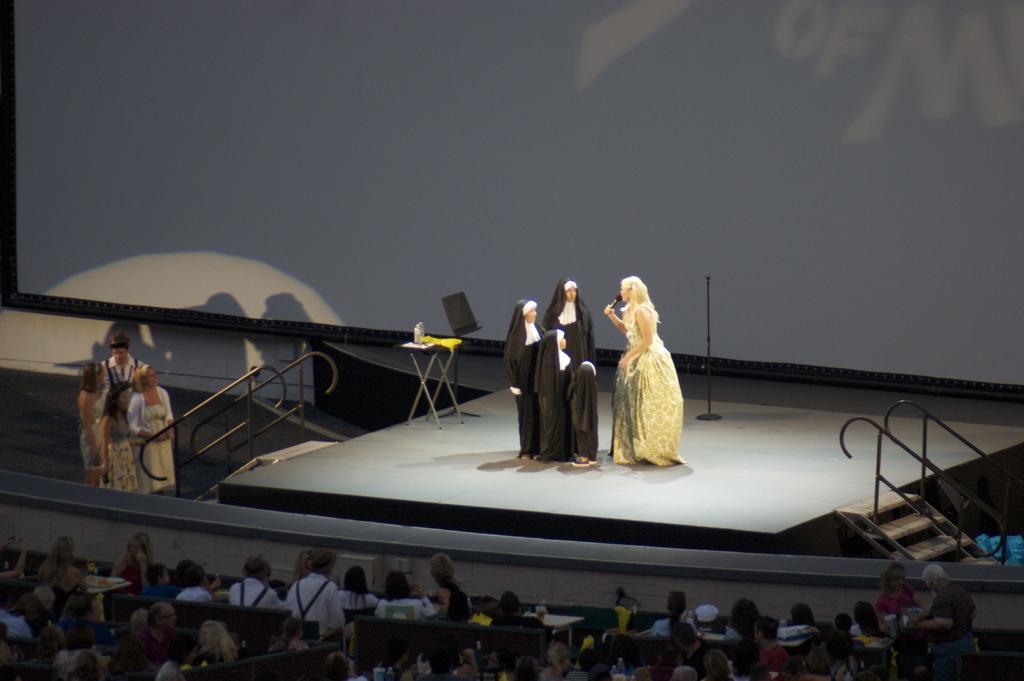How would you summarize this image in a sentence or two? In the picture we can see a play on the stage and near it, we can see a few people are standing near the railing and behind them we can see audience are sitting and watching the play. 